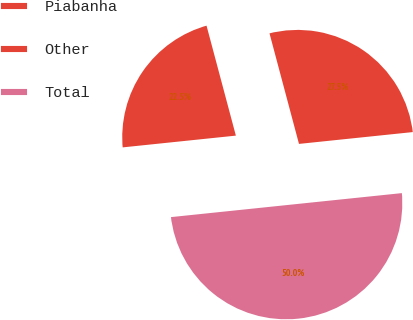Convert chart to OTSL. <chart><loc_0><loc_0><loc_500><loc_500><pie_chart><fcel>Piabanha<fcel>Other<fcel>Total<nl><fcel>27.5%<fcel>22.5%<fcel>50.0%<nl></chart> 